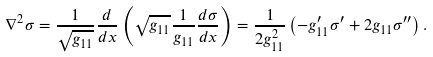<formula> <loc_0><loc_0><loc_500><loc_500>\nabla ^ { 2 } \sigma = \frac { 1 } { \sqrt { g _ { 1 1 } } } \frac { d } { d x } \left ( \sqrt { g _ { 1 1 } } \frac { 1 } { g _ { 1 1 } } \frac { d \sigma } { d x } \right ) = \frac { 1 } { 2 g _ { 1 1 } ^ { 2 } } \left ( - g _ { 1 1 } ^ { \prime } \sigma ^ { \prime } + 2 g _ { 1 1 } \sigma ^ { \prime \prime } \right ) .</formula> 